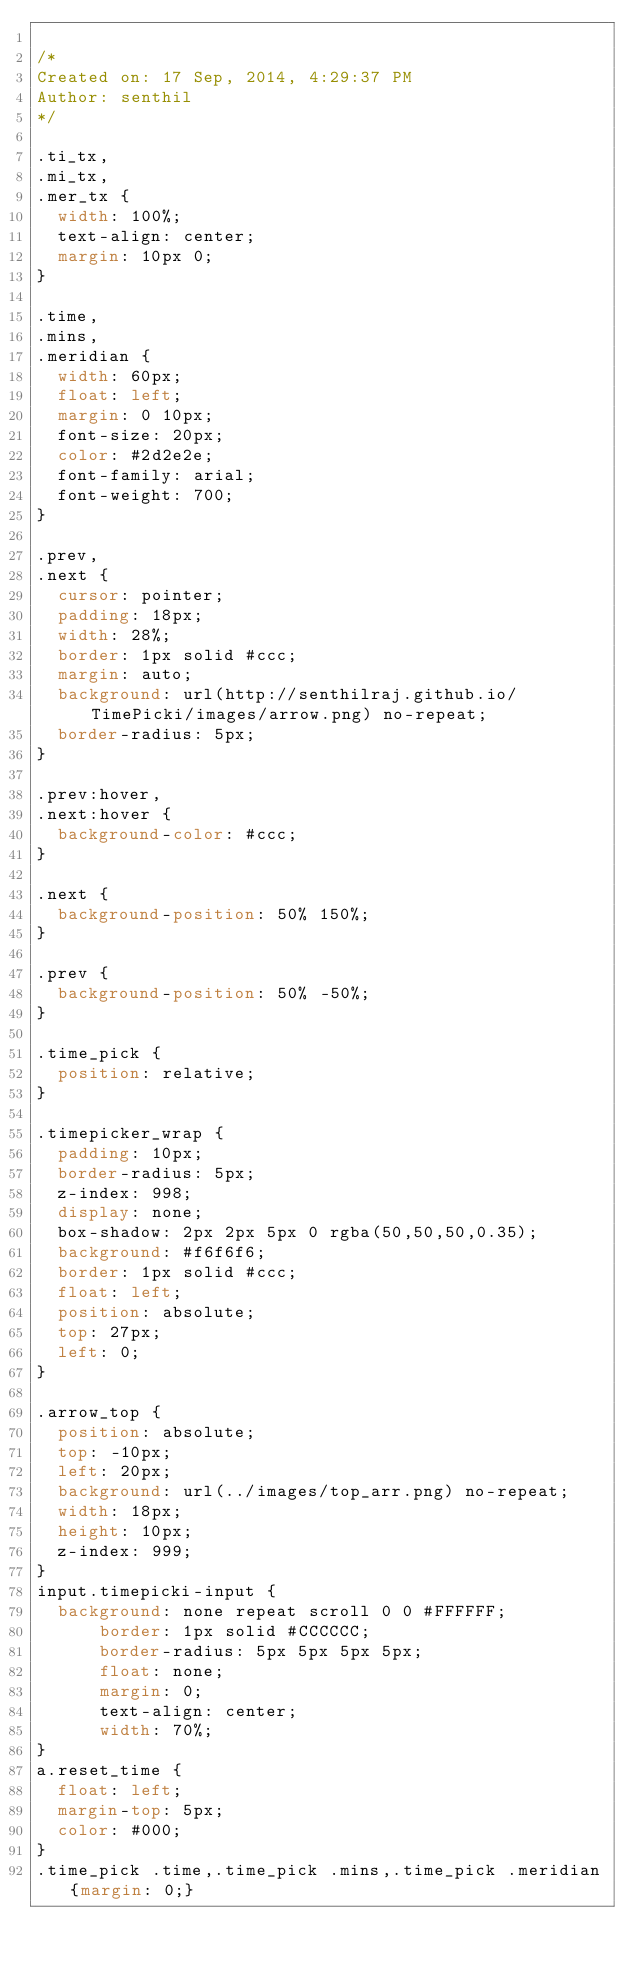<code> <loc_0><loc_0><loc_500><loc_500><_CSS_>
/* 
Created on: 17 Sep, 2014, 4:29:37 PM
Author: senthil
*/

.ti_tx,
.mi_tx,
.mer_tx {
	width: 100%;
	text-align: center;
	margin: 10px 0;
}

.time,
.mins,
.meridian {
	width: 60px;
	float: left;
	margin: 0 10px;
	font-size: 20px;
	color: #2d2e2e;
	font-family: arial;
	font-weight: 700;
}

.prev,
.next {
	cursor: pointer;
	padding: 18px;
	width: 28%;
	border: 1px solid #ccc;
	margin: auto;
	background: url(http://senthilraj.github.io/TimePicki/images/arrow.png) no-repeat;
	border-radius: 5px;
}

.prev:hover,
.next:hover {
	background-color: #ccc;
}

.next {
	background-position: 50% 150%;
}

.prev {
	background-position: 50% -50%;
}

.time_pick {
	position: relative;
}

.timepicker_wrap {
	padding: 10px;
	border-radius: 5px;
	z-index: 998;
	display: none;
	box-shadow: 2px 2px 5px 0 rgba(50,50,50,0.35);
	background: #f6f6f6;
	border: 1px solid #ccc;
	float: left;
	position: absolute;
	top: 27px;
	left: 0;
}

.arrow_top {
	position: absolute;
	top: -10px;
	left: 20px;
	background: url(../images/top_arr.png) no-repeat;
	width: 18px;
	height: 10px;
	z-index: 999;
}
input.timepicki-input {
	background: none repeat scroll 0 0 #FFFFFF;
    	border: 1px solid #CCCCCC;
    	border-radius: 5px 5px 5px 5px;
    	float: none;
    	margin: 0;
    	text-align: center;
    	width: 70%;
}
a.reset_time {
	float: left;
	margin-top: 5px;
	color: #000;
}
.time_pick .time,.time_pick .mins,.time_pick .meridian{margin: 0;}</code> 